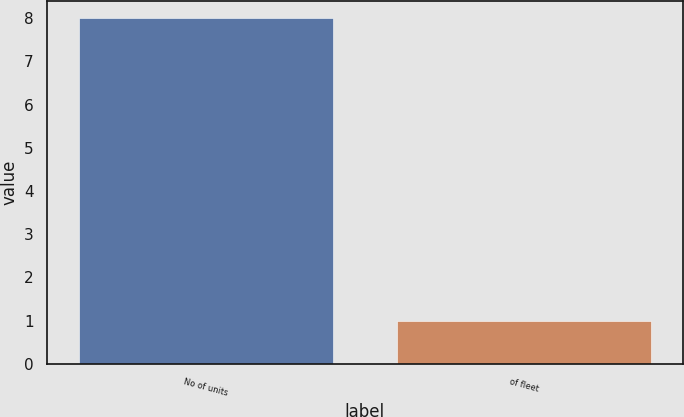Convert chart to OTSL. <chart><loc_0><loc_0><loc_500><loc_500><bar_chart><fcel>No of units<fcel>of fleet<nl><fcel>8<fcel>1<nl></chart> 